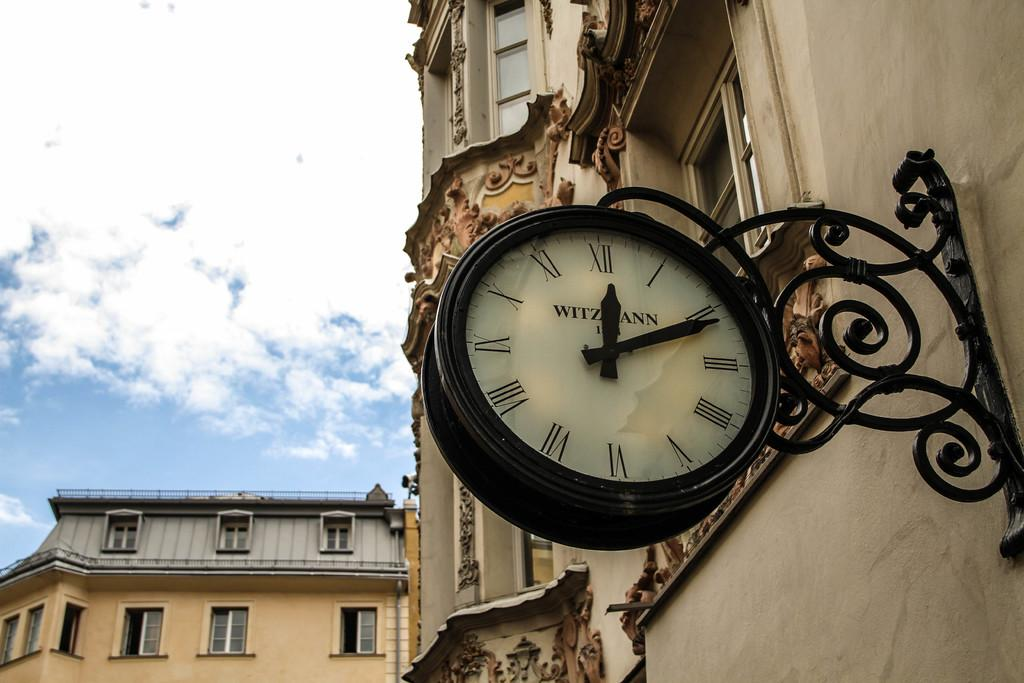Provide a one-sentence caption for the provided image. An outdoor clock attached to a building shows that is is 12:11. 